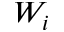Convert formula to latex. <formula><loc_0><loc_0><loc_500><loc_500>W _ { i }</formula> 